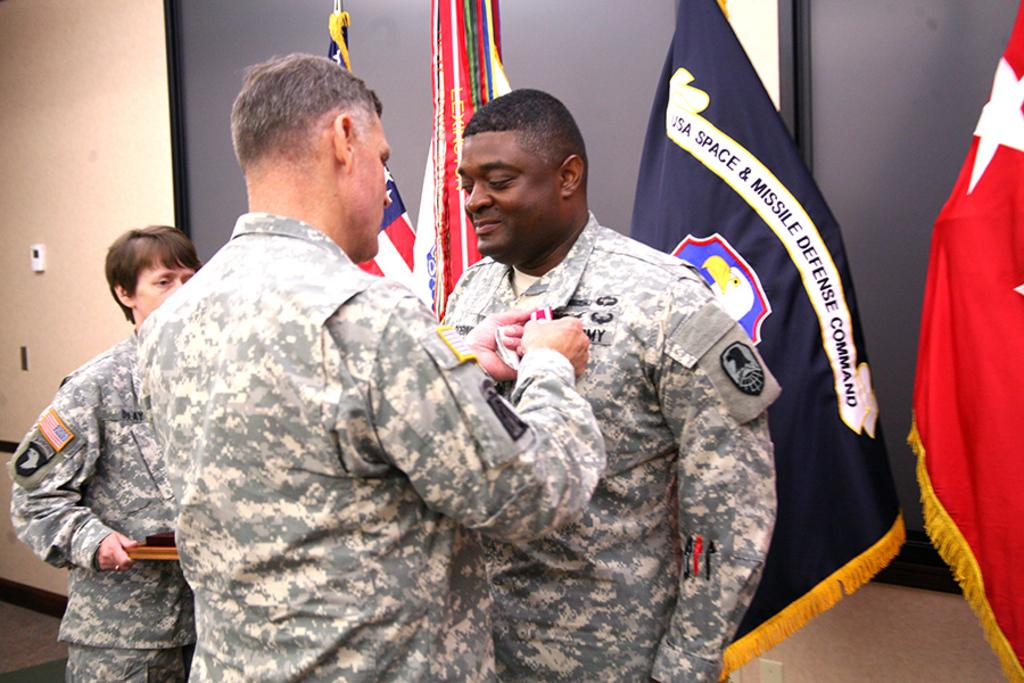<image>
Relay a brief, clear account of the picture shown. an army official being sworn in, it seems with a flag behind him that says USA SPACE & MISSLE DEFENSE COMMAND 